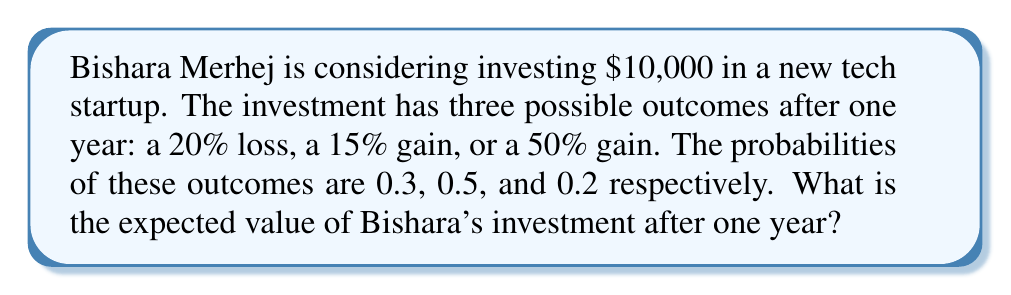Can you answer this question? To calculate the expected value of Bishara's investment, we need to follow these steps:

1. Identify the possible outcomes and their probabilities:
   - 20% loss: probability = 0.3
   - 15% gain: probability = 0.5
   - 50% gain: probability = 0.2

2. Calculate the value of the investment for each outcome:
   - 20% loss: $10,000 × (1 - 0.20) = $8,000
   - 15% gain: $10,000 × (1 + 0.15) = $11,500
   - 50% gain: $10,000 × (1 + 0.50) = $15,000

3. Calculate the expected value using the formula:
   $$ E(X) = \sum_{i=1}^{n} x_i \cdot p_i $$
   where $x_i$ is the value of each outcome and $p_i$ is its probability.

4. Plug in the values:
   $$ E(X) = 8,000 \cdot 0.3 + 11,500 \cdot 0.5 + 15,000 \cdot 0.2 $$

5. Compute the result:
   $$ E(X) = 2,400 + 5,750 + 3,000 = 11,150 $$

Therefore, the expected value of Bishara's investment after one year is $11,150.
Answer: $11,150 